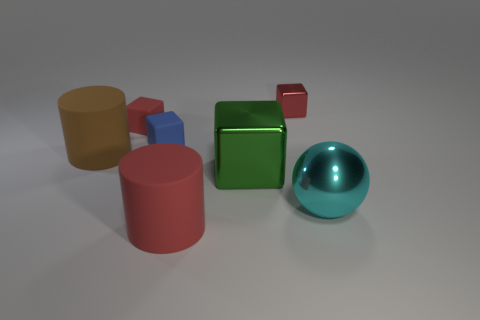Subtract all green spheres. How many red blocks are left? 2 Subtract all green shiny blocks. How many blocks are left? 3 Subtract 1 cubes. How many cubes are left? 3 Subtract all green cubes. How many cubes are left? 3 Subtract all brown blocks. Subtract all cyan cylinders. How many blocks are left? 4 Add 1 large red cylinders. How many objects exist? 8 Subtract all balls. How many objects are left? 6 Subtract all red things. Subtract all cyan objects. How many objects are left? 3 Add 3 cylinders. How many cylinders are left? 5 Add 1 metal balls. How many metal balls exist? 2 